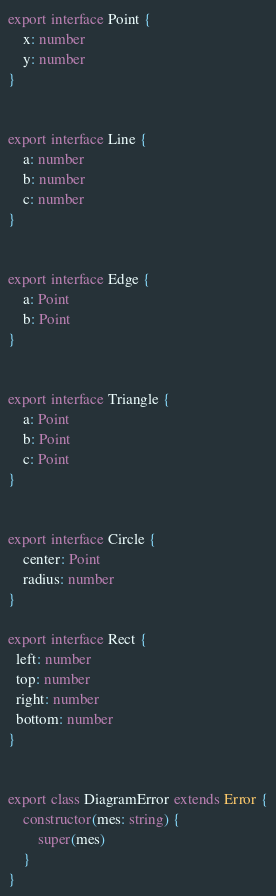<code> <loc_0><loc_0><loc_500><loc_500><_TypeScript_>
export interface Point {
	x: number
	y: number
}


export interface Line {
	a: number
	b: number
	c: number
}


export interface Edge {
	a: Point
	b: Point
}


export interface Triangle {
	a: Point
	b: Point
	c: Point
}


export interface Circle {
	center: Point
	radius: number
}

export interface Rect {
  left: number
  top: number
  right: number
  bottom: number
}


export class DiagramError extends Error {
	constructor(mes: string) {
		super(mes)
	}
}</code> 